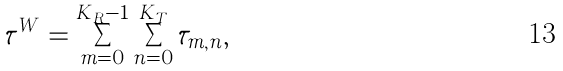Convert formula to latex. <formula><loc_0><loc_0><loc_500><loc_500>\tau ^ { W } = \sum _ { m = 0 } ^ { K _ { R } - 1 } \sum _ { n = 0 } ^ { K _ { T } } \tau _ { m , n } ,</formula> 